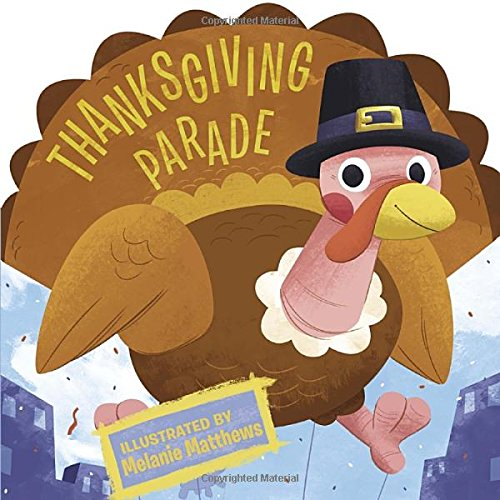What is the genre of this book? This book belongs to the genre of Children's Books, specifically focusing on holiday-themed picture books for young children. 